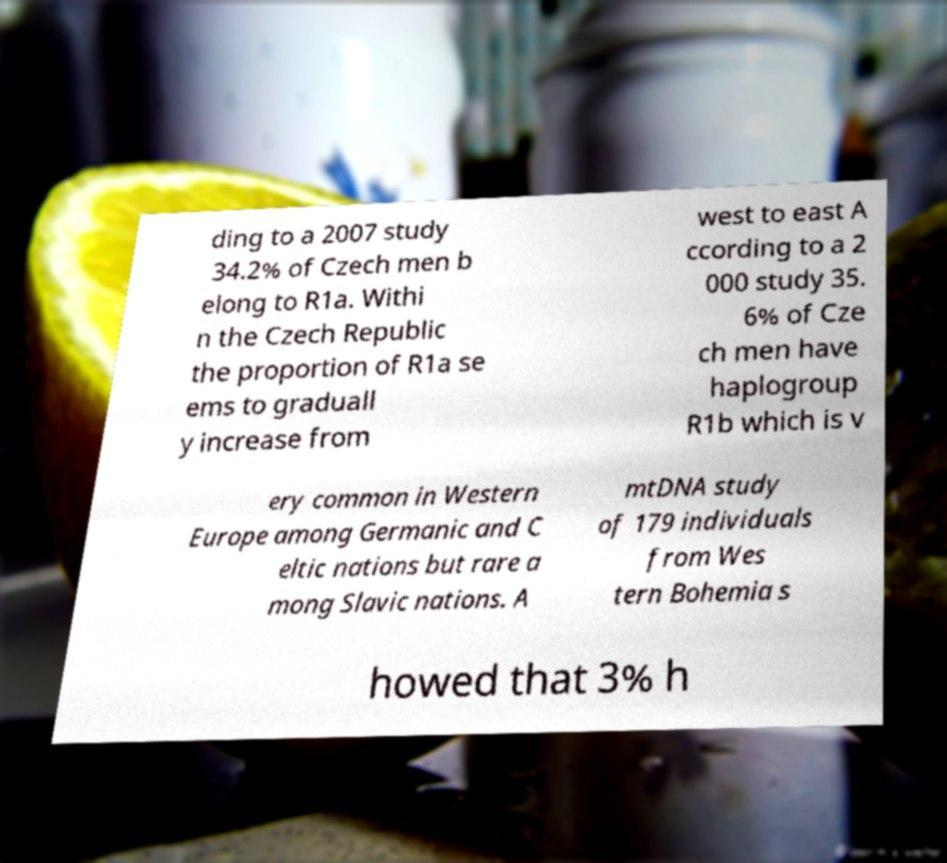Please read and relay the text visible in this image. What does it say? ding to a 2007 study 34.2% of Czech men b elong to R1a. Withi n the Czech Republic the proportion of R1a se ems to graduall y increase from west to east A ccording to a 2 000 study 35. 6% of Cze ch men have haplogroup R1b which is v ery common in Western Europe among Germanic and C eltic nations but rare a mong Slavic nations. A mtDNA study of 179 individuals from Wes tern Bohemia s howed that 3% h 